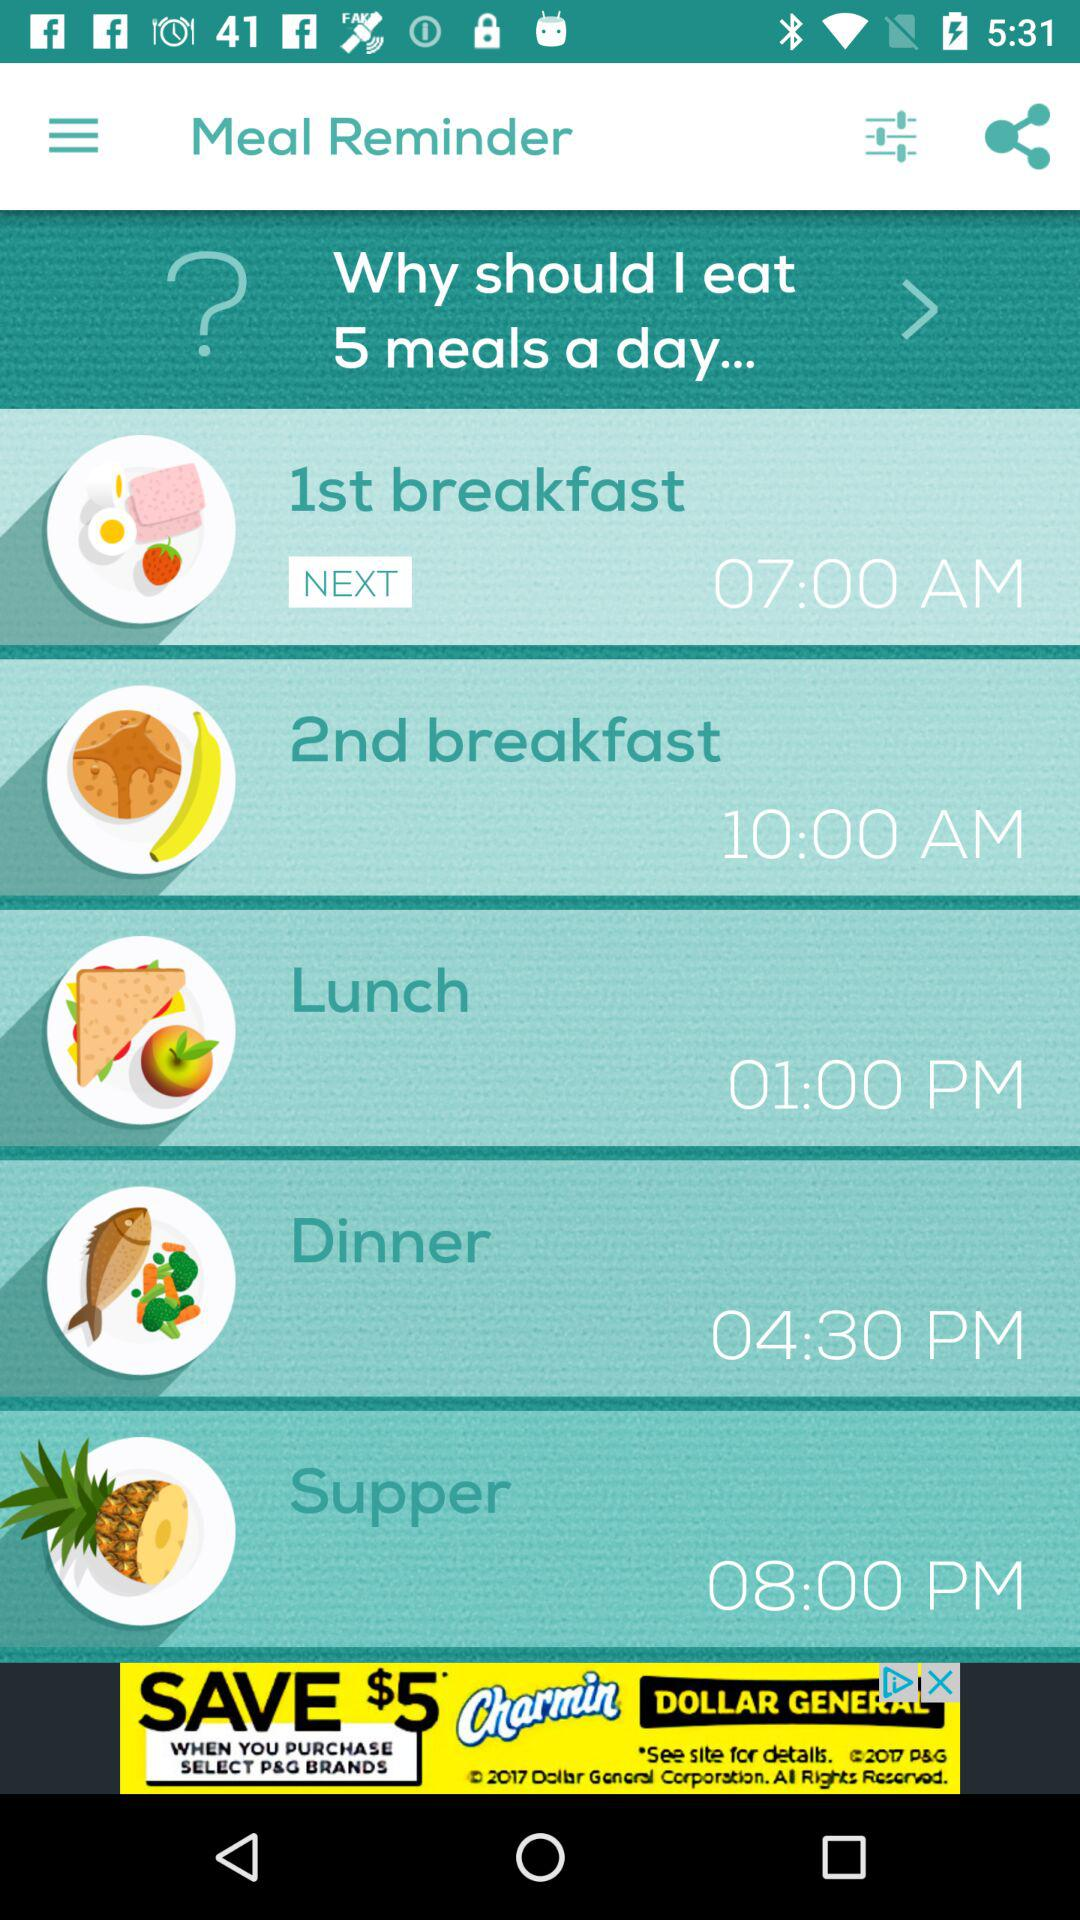Can this meal schedule be beneficial for everyone? Meal schedules are quite individual—while some may benefit from five smaller meals due to their metabolism, activity level, or diet plans, others might do better with three larger meals or a different pattern entirely. 